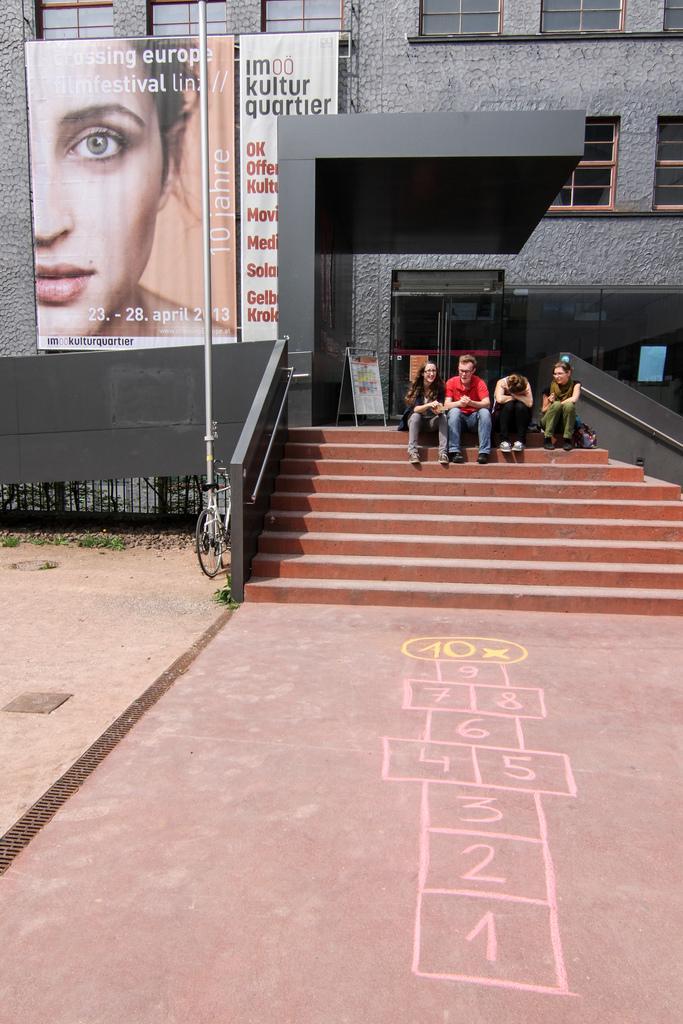Please provide a concise description of this image. In this image there are a few people sitting on the stairs in front of a building, behind the stairs there is a menu board, on the building there is a banner, in front of the building there is a pole, beside the pole there is a cycle, in front of the stairs on the pavement there are some numbers written on the surface. 